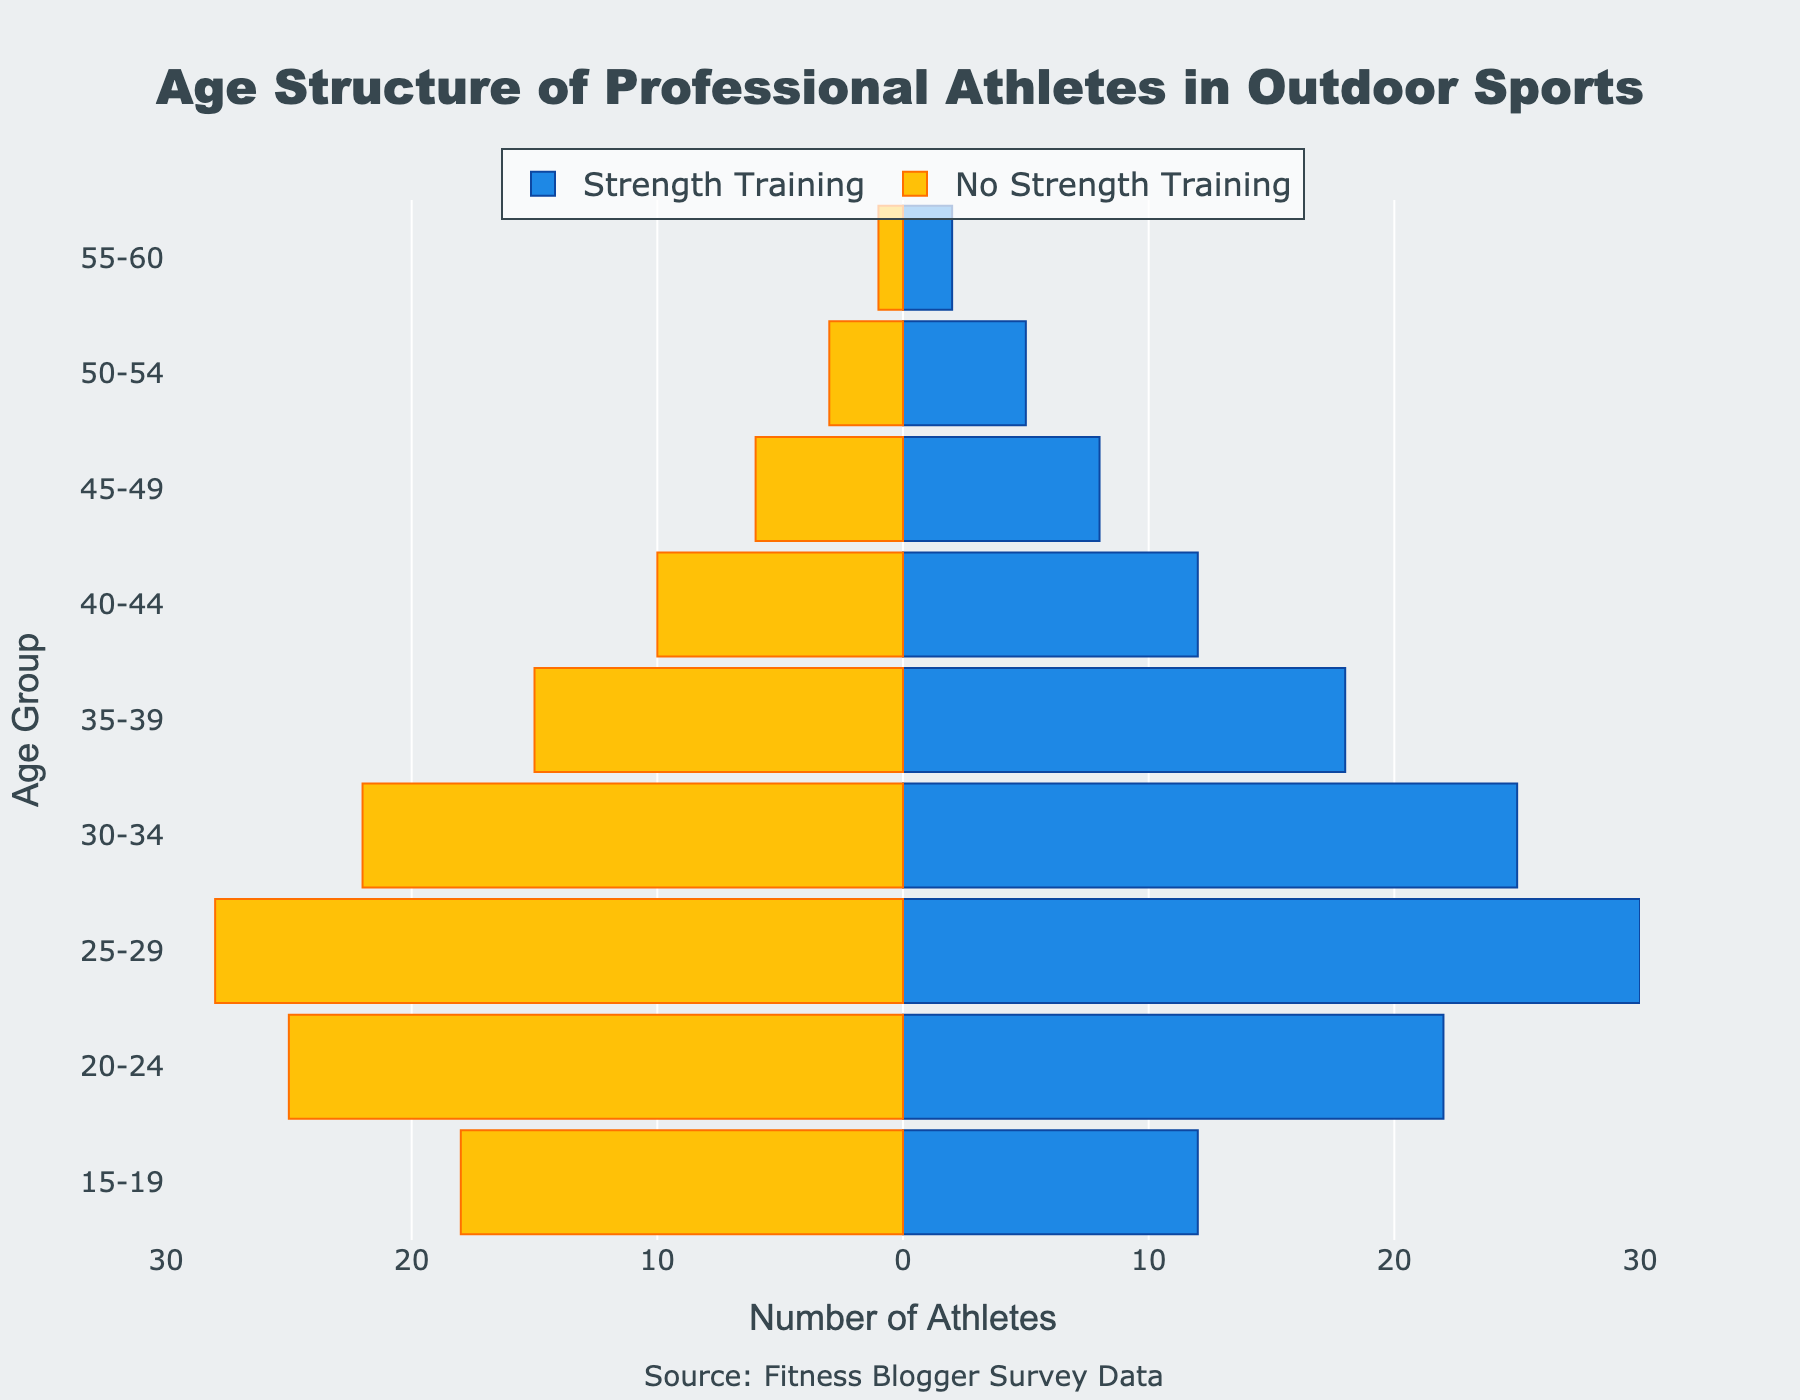What is the title of the chart? The title of the chart is located at the top of the figure. It reads "Age Structure of Professional Athletes in Outdoor Sports."
Answer: Age Structure of Professional Athletes in Outdoor Sports How many age groups are represented in the chart? The y-axis lists the age groups shown in the figure. Each age group represents a range of years. Counting these groups gives us nine age groups in total.
Answer: Nine What is the color scheme used for the athletes who do strength training? The bars representing athletes who do strength training are colored blue.
Answer: Blue Which age group has the highest number of athletes who do strength training? The age group with the longest blue bar represents the highest number of athletes doing strength training. This group is 25-29, with a bar reaching up to 30.
Answer: 25-29 Which age group has the least number of athletes who do not do strength training? The age group with the shortest yellow bar represents the least number of athletes not doing strength training. This group is 55-60, with a bar reaching up to 1.
Answer: 55-60 What is the difference between the number of athletes who do and do not do strength training in the 30-34 age group? The number of athletes who do strength training in the 30-34 group is 25, while the number who do not is 22. The difference between these two numbers is 25 - 22 = 3.
Answer: 3 For the age group 15-19, how many more athletes do not incorporate strength training compared to those who do? In the 15-19 age group, the number of athletes who do strength training is 12, while those who do not is 18. The difference is 18 - 12 = 6.
Answer: 6 Do more athletes overall in the age group 20-24 incorporate strength training or not? In the age group 20-24, the figure shows that 22 athletes incorporate strength training, while 25 do not. Thus, more athletes do not incorporate strength training.
Answer: Not By examining the chart, what can you infer about the trend of strength training incorporation among professional athletes as they age? Observing the figure, athletes tend to incorporate strength training more into their routines mostly in the middle-age groups (25 to 34). However, as they get older beyond 35, the number of athletes incorporating strength training generally decreases.
Answer: Incorporation decreases with age What is the total number of athletes in the age group 50-54 for both those incorporating strength training and those who do not? In the age group 50-54, 5 athletes incorporate strength training, and 3 do not. Adding these numbers together, the total is 5 + 3 = 8.
Answer: 8 